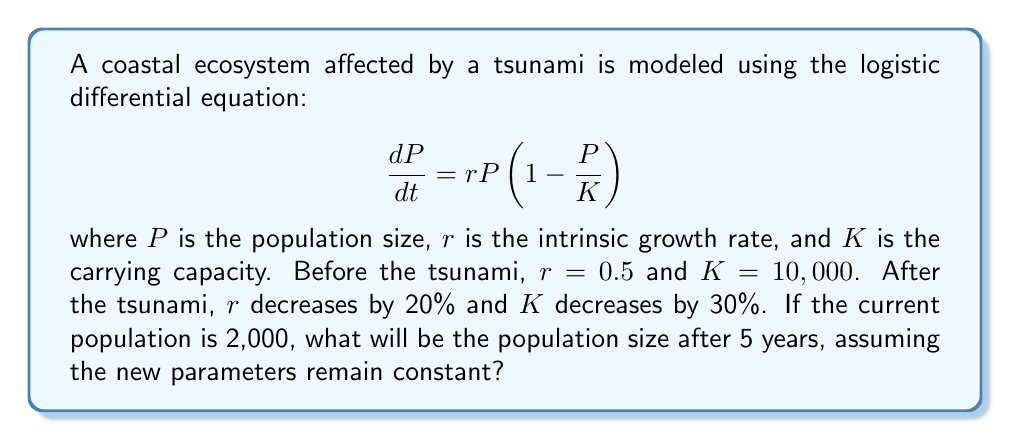Can you solve this math problem? 1. Identify the new parameters:
   New $r = 0.5 \times (1 - 0.2) = 0.4$
   New $K = 10,000 \times (1 - 0.3) = 7,000$

2. The solution to the logistic differential equation is:
   $$P(t) = \frac{KP_0e^{rt}}{K + P_0(e^{rt} - 1)}$$
   where $P_0$ is the initial population.

3. Substitute the known values:
   $P_0 = 2,000$, $K = 7,000$, $r = 0.4$, $t = 5$

4. Calculate:
   $$P(5) = \frac{7,000 \times 2,000 \times e^{0.4 \times 5}}{7,000 + 2,000(e^{0.4 \times 5} - 1)}$$

5. Evaluate $e^{0.4 \times 5} = e^2 \approx 7.3891$

6. Substitute and calculate:
   $$P(5) = \frac{7,000 \times 2,000 \times 7.3891}{7,000 + 2,000(7.3891 - 1)}$$
   $$= \frac{103,447,400}{7,000 + 12,778.2}$$
   $$= \frac{103,447,400}{19,778.2}$$
   $$\approx 5,230.39$$

7. Round to the nearest whole number:
   $P(5) \approx 5,230$
Answer: 5,230 